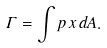Convert formula to latex. <formula><loc_0><loc_0><loc_500><loc_500>\Gamma = \int p \, x \, d A .</formula> 